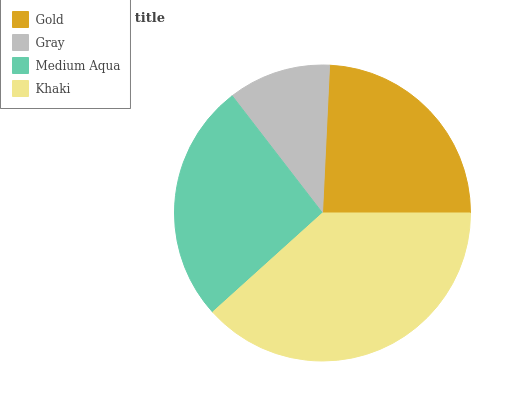Is Gray the minimum?
Answer yes or no. Yes. Is Khaki the maximum?
Answer yes or no. Yes. Is Medium Aqua the minimum?
Answer yes or no. No. Is Medium Aqua the maximum?
Answer yes or no. No. Is Medium Aqua greater than Gray?
Answer yes or no. Yes. Is Gray less than Medium Aqua?
Answer yes or no. Yes. Is Gray greater than Medium Aqua?
Answer yes or no. No. Is Medium Aqua less than Gray?
Answer yes or no. No. Is Medium Aqua the high median?
Answer yes or no. Yes. Is Gold the low median?
Answer yes or no. Yes. Is Gold the high median?
Answer yes or no. No. Is Khaki the low median?
Answer yes or no. No. 